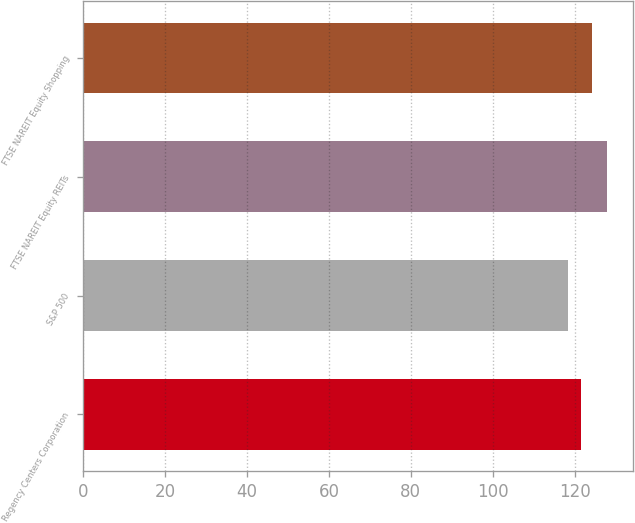Convert chart to OTSL. <chart><loc_0><loc_0><loc_500><loc_500><bar_chart><fcel>Regency Centers Corporation<fcel>S&P 500<fcel>FTSE NAREIT Equity REITs<fcel>FTSE NAREIT Equity Shopping<nl><fcel>121.45<fcel>118.45<fcel>127.85<fcel>124.11<nl></chart> 